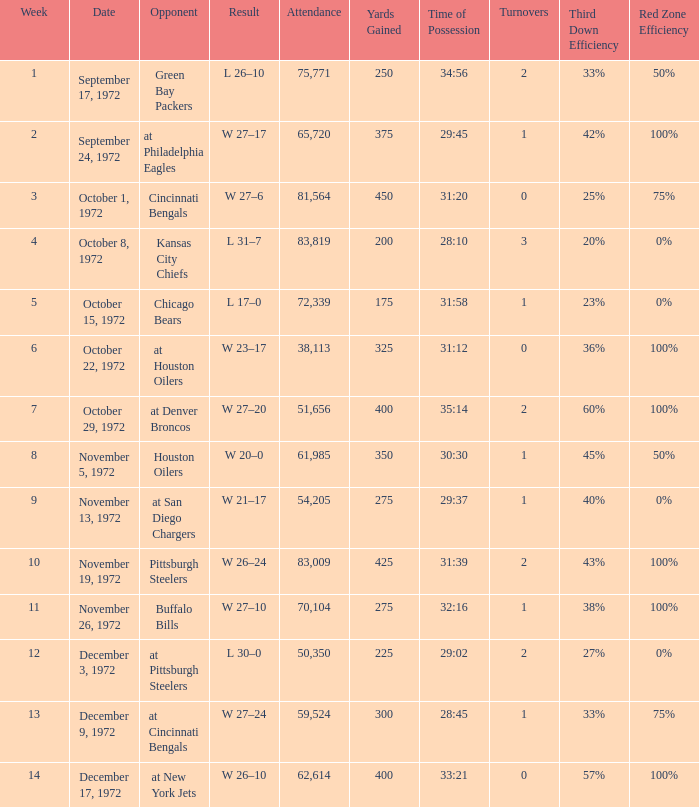Parse the table in full. {'header': ['Week', 'Date', 'Opponent', 'Result', 'Attendance', 'Yards Gained', 'Time of Possession', 'Turnovers', 'Third Down Efficiency', 'Red Zone Efficiency'], 'rows': [['1', 'September 17, 1972', 'Green Bay Packers', 'L 26–10', '75,771', '250', '34:56', '2', '33%', '50%'], ['2', 'September 24, 1972', 'at Philadelphia Eagles', 'W 27–17', '65,720', '375', '29:45', '1', '42%', '100%'], ['3', 'October 1, 1972', 'Cincinnati Bengals', 'W 27–6', '81,564', '450', '31:20', '0', '25%', '75%'], ['4', 'October 8, 1972', 'Kansas City Chiefs', 'L 31–7', '83,819', '200', '28:10', '3', '20%', '0%'], ['5', 'October 15, 1972', 'Chicago Bears', 'L 17–0', '72,339', '175', '31:58', '1', '23%', '0%'], ['6', 'October 22, 1972', 'at Houston Oilers', 'W 23–17', '38,113', '325', '31:12', '0', '36%', '100%'], ['7', 'October 29, 1972', 'at Denver Broncos', 'W 27–20', '51,656', '400', '35:14', '2', '60%', '100%'], ['8', 'November 5, 1972', 'Houston Oilers', 'W 20–0', '61,985', '350', '30:30', '1', '45%', '50%'], ['9', 'November 13, 1972', 'at San Diego Chargers', 'W 21–17', '54,205', '275', '29:37', '1', '40%', '0%'], ['10', 'November 19, 1972', 'Pittsburgh Steelers', 'W 26–24', '83,009', '425', '31:39', '2', '43%', '100%'], ['11', 'November 26, 1972', 'Buffalo Bills', 'W 27–10', '70,104', '275', '32:16', '1', '38%', '100%'], ['12', 'December 3, 1972', 'at Pittsburgh Steelers', 'L 30–0', '50,350', '225', '29:02', '2', '27%', '0%'], ['13', 'December 9, 1972', 'at Cincinnati Bengals', 'W 27–24', '59,524', '300', '28:45', '1', '33%', '75%'], ['14', 'December 17, 1972', 'at New York Jets', 'W 26–10', '62,614', '400', '33:21', '0', '57%', '100%']]} What is the sum of week number(s) had an attendance of 61,985? 1.0. 